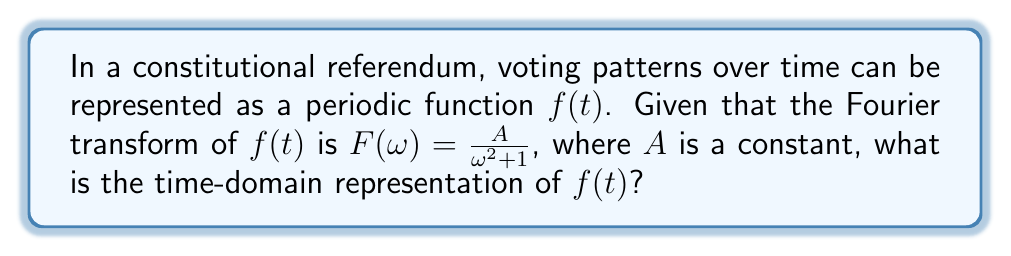Could you help me with this problem? To find the time-domain representation of $f(t)$, we need to apply the inverse Fourier transform to $F(\omega)$. The steps are as follows:

1) The given Fourier transform is:

   $$F(\omega) = \frac{A}{\omega^2 + 1}$$

2) This form resembles the Fourier transform of an exponential decay function. Specifically, it corresponds to:

   $$f(t) = A\pi e^{-|t|}$$

3) To verify this, we can take the Fourier transform of $A\pi e^{-|t|}$:

   $$\mathcal{F}\{A\pi e^{-|t|}\} = A\pi \int_{-\infty}^{\infty} e^{-|t|} e^{-i\omega t} dt$$

4) This integral can be split into two parts:

   $$A\pi \left(\int_{-\infty}^{0} e^{t} e^{-i\omega t} dt + \int_{0}^{\infty} e^{-t} e^{-i\omega t} dt\right)$$

5) Evaluating these integrals:

   $$A\pi \left(\frac{1}{1+i\omega} + \frac{1}{1-i\omega}\right) = A\pi \frac{2}{1+\omega^2} = \frac{A}{\omega^2 + 1}$$

6) This matches our original $F(\omega)$, confirming that $f(t) = A\pi e^{-|t|}$ is indeed the correct time-domain representation.

In the context of voting patterns, this function suggests that the influence of a referendum decays exponentially over time in both directions from the moment of the vote.
Answer: $f(t) = A\pi e^{-|t|}$ 